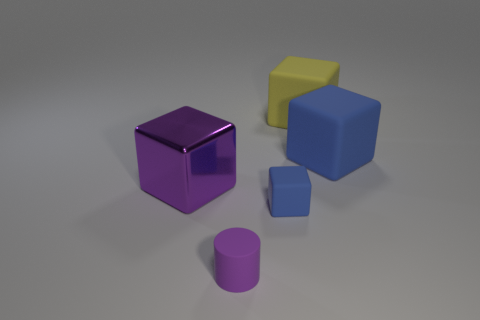What is the shape of the purple metallic thing?
Give a very brief answer. Cube. There is a large object that is both in front of the yellow object and on the right side of the purple cylinder; what is its color?
Give a very brief answer. Blue. The other rubber thing that is the same size as the yellow rubber thing is what shape?
Provide a short and direct response. Cube. Is there a small blue rubber thing that has the same shape as the purple metal thing?
Keep it short and to the point. Yes. Does the small cylinder have the same material as the blue block to the right of the big yellow rubber cube?
Provide a succinct answer. Yes. The small matte object that is to the right of the tiny purple thing in front of the large rubber block that is right of the large yellow thing is what color?
Keep it short and to the point. Blue. There is a cube that is the same size as the purple cylinder; what is its material?
Make the answer very short. Rubber. What number of yellow things are the same material as the tiny cylinder?
Make the answer very short. 1. Is the size of the object on the left side of the tiny purple cylinder the same as the blue rubber block that is to the left of the large yellow rubber object?
Offer a terse response. No. The big object that is left of the small purple cylinder is what color?
Offer a very short reply. Purple. 